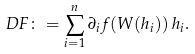Convert formula to latex. <formula><loc_0><loc_0><loc_500><loc_500>D F \colon = \sum _ { i = 1 } ^ { n } \partial _ { i } f ( W ( h _ { i } ) ) \, h _ { i } .</formula> 